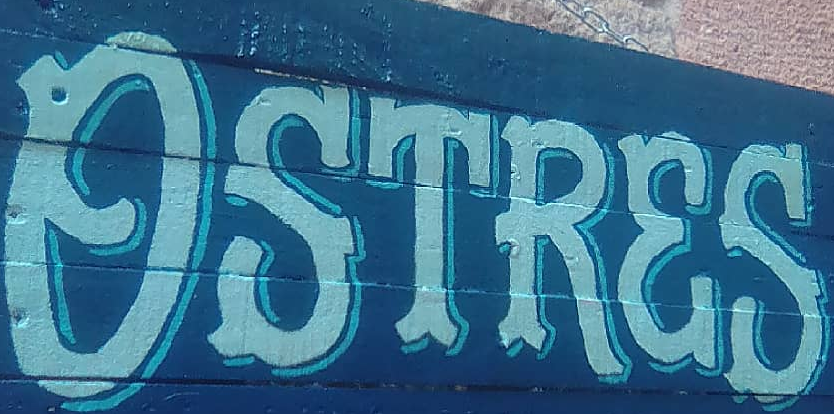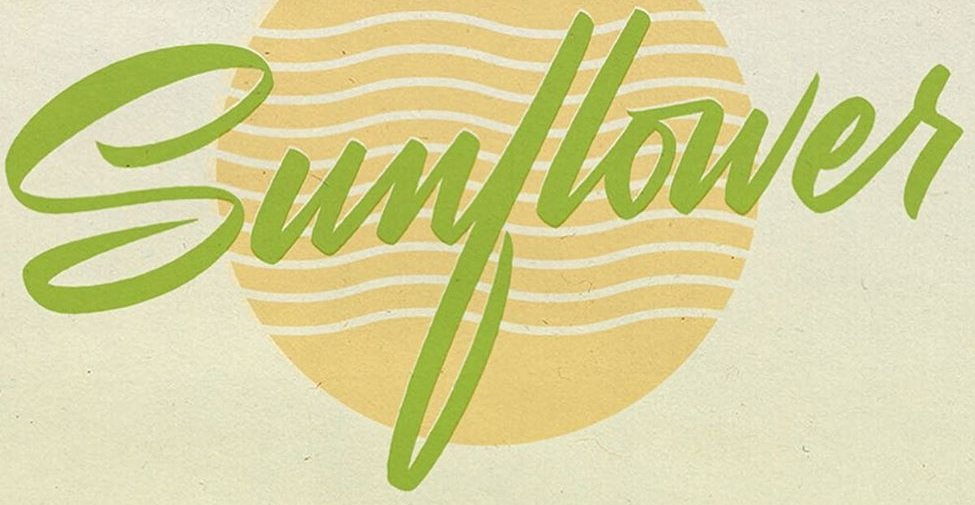What words can you see in these images in sequence, separated by a semicolon? OSTRES; Sunflowes 